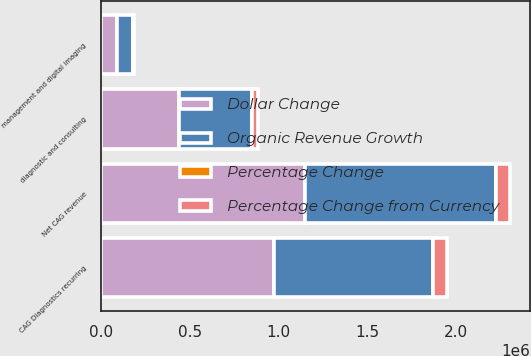Convert chart. <chart><loc_0><loc_0><loc_500><loc_500><stacked_bar_chart><ecel><fcel>CAG Diagnostics recurring<fcel>diagnostic and consulting<fcel>management and digital imaging<fcel>Net CAG revenue<nl><fcel>Dollar Change<fcel>974004<fcel>441207<fcel>92791<fcel>1.15017e+06<nl><fcel>Organic Revenue Growth<fcel>896449<fcel>407343<fcel>85585<fcel>1.07221e+06<nl><fcel>Percentage Change from Currency<fcel>77555<fcel>33864<fcel>7206<fcel>77958<nl><fcel>Percentage Change<fcel>8.7<fcel>8.3<fcel>8.4<fcel>7.3<nl></chart> 